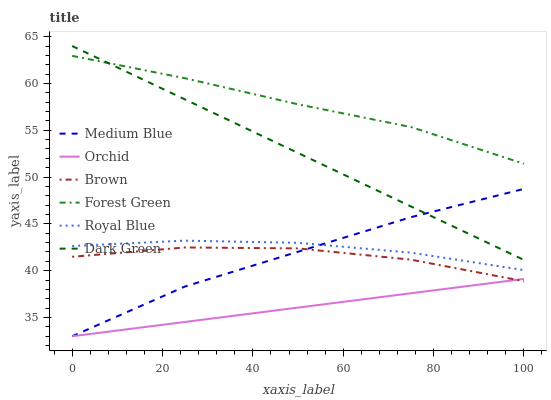Does Orchid have the minimum area under the curve?
Answer yes or no. Yes. Does Forest Green have the maximum area under the curve?
Answer yes or no. Yes. Does Medium Blue have the minimum area under the curve?
Answer yes or no. No. Does Medium Blue have the maximum area under the curve?
Answer yes or no. No. Is Orchid the smoothest?
Answer yes or no. Yes. Is Brown the roughest?
Answer yes or no. Yes. Is Medium Blue the smoothest?
Answer yes or no. No. Is Medium Blue the roughest?
Answer yes or no. No. Does Medium Blue have the lowest value?
Answer yes or no. Yes. Does Royal Blue have the lowest value?
Answer yes or no. No. Does Dark Green have the highest value?
Answer yes or no. Yes. Does Medium Blue have the highest value?
Answer yes or no. No. Is Royal Blue less than Dark Green?
Answer yes or no. Yes. Is Forest Green greater than Brown?
Answer yes or no. Yes. Does Brown intersect Orchid?
Answer yes or no. Yes. Is Brown less than Orchid?
Answer yes or no. No. Is Brown greater than Orchid?
Answer yes or no. No. Does Royal Blue intersect Dark Green?
Answer yes or no. No. 